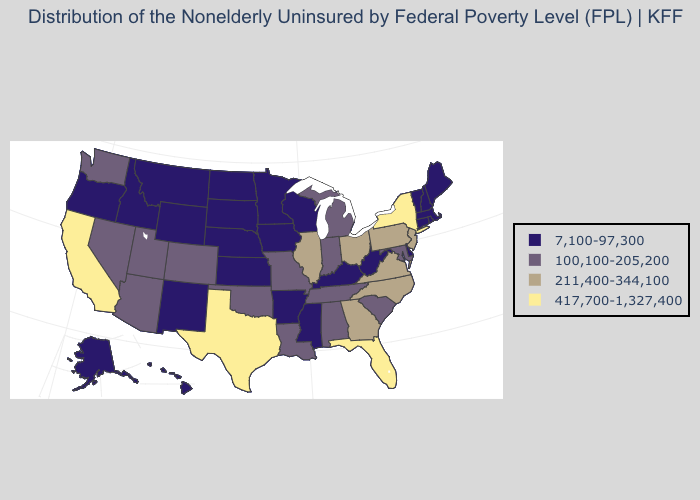What is the value of Pennsylvania?
Concise answer only. 211,400-344,100. What is the value of South Dakota?
Quick response, please. 7,100-97,300. Name the states that have a value in the range 417,700-1,327,400?
Keep it brief. California, Florida, New York, Texas. What is the value of Nebraska?
Give a very brief answer. 7,100-97,300. What is the lowest value in the South?
Answer briefly. 7,100-97,300. Among the states that border Georgia , which have the highest value?
Give a very brief answer. Florida. Name the states that have a value in the range 7,100-97,300?
Short answer required. Alaska, Arkansas, Connecticut, Delaware, Hawaii, Idaho, Iowa, Kansas, Kentucky, Maine, Massachusetts, Minnesota, Mississippi, Montana, Nebraska, New Hampshire, New Mexico, North Dakota, Oregon, Rhode Island, South Dakota, Vermont, West Virginia, Wisconsin, Wyoming. Name the states that have a value in the range 211,400-344,100?
Answer briefly. Georgia, Illinois, New Jersey, North Carolina, Ohio, Pennsylvania, Virginia. Does Minnesota have the same value as New York?
Short answer required. No. Which states have the highest value in the USA?
Keep it brief. California, Florida, New York, Texas. Name the states that have a value in the range 417,700-1,327,400?
Concise answer only. California, Florida, New York, Texas. What is the highest value in states that border Alabama?
Concise answer only. 417,700-1,327,400. What is the value of Louisiana?
Write a very short answer. 100,100-205,200. What is the value of Texas?
Concise answer only. 417,700-1,327,400. 